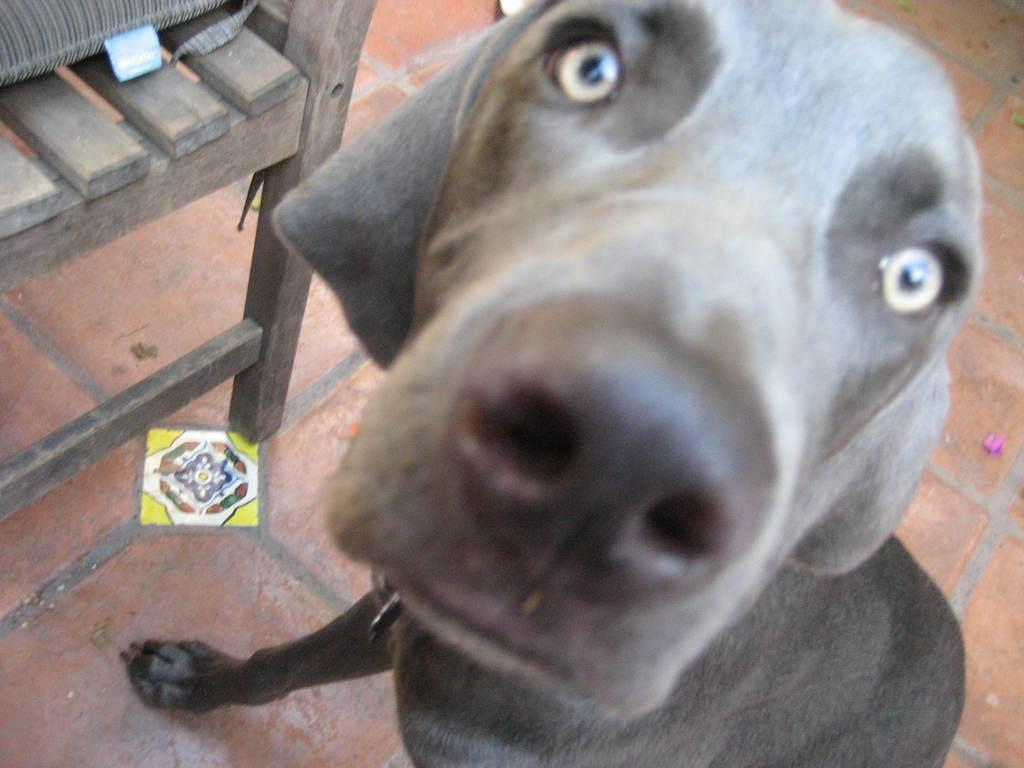What type of animal is in the image? There is a dog in the image. What color is the dog? The dog is black in color. What is visible beneath the dog in the image? There is a floor visible in the image. What type of furniture can be seen on the left side of the image? There is a wooden bench on the left side of the image. What type of advertisement is displayed on the dog in the image? There is no advertisement displayed on the dog in the image; it is simply a black dog. What type of beast is present in the image? There is no beast present in the image; only a dog is visible. 